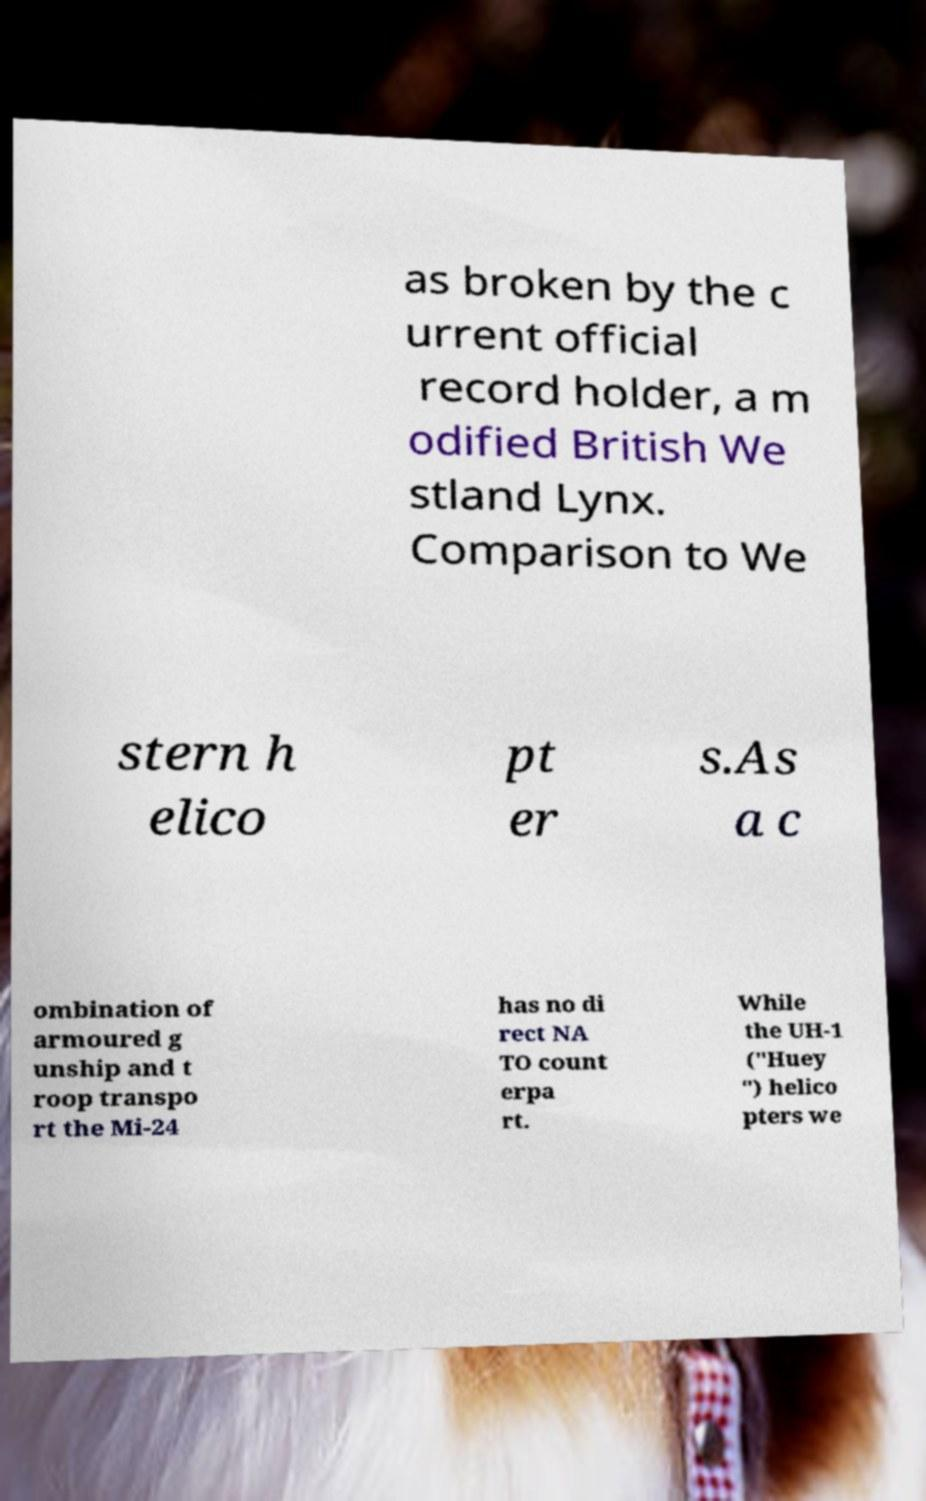There's text embedded in this image that I need extracted. Can you transcribe it verbatim? as broken by the c urrent official record holder, a m odified British We stland Lynx. Comparison to We stern h elico pt er s.As a c ombination of armoured g unship and t roop transpo rt the Mi-24 has no di rect NA TO count erpa rt. While the UH-1 ("Huey ") helico pters we 